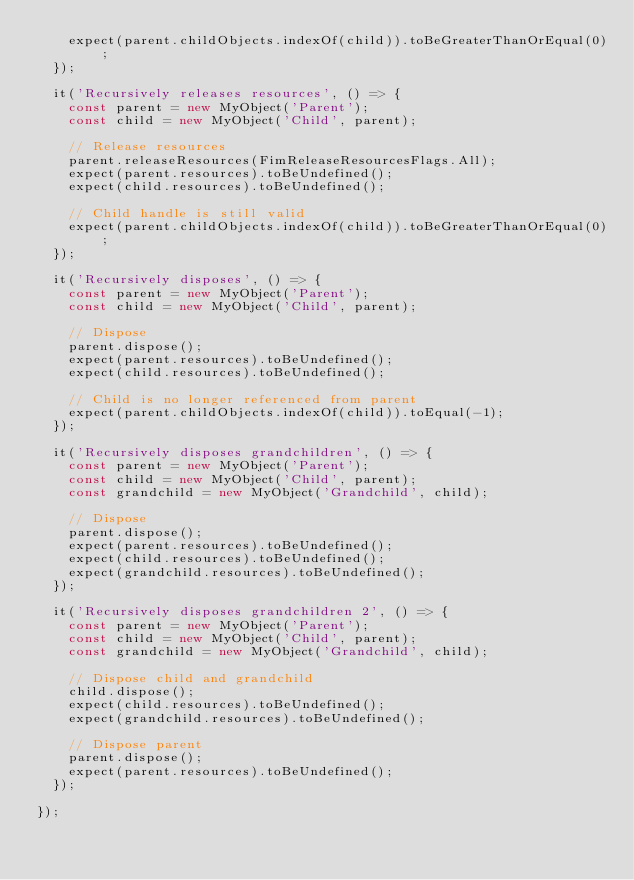Convert code to text. <code><loc_0><loc_0><loc_500><loc_500><_TypeScript_>    expect(parent.childObjects.indexOf(child)).toBeGreaterThanOrEqual(0);
  });

  it('Recursively releases resources', () => {
    const parent = new MyObject('Parent');
    const child = new MyObject('Child', parent);

    // Release resources
    parent.releaseResources(FimReleaseResourcesFlags.All);
    expect(parent.resources).toBeUndefined();
    expect(child.resources).toBeUndefined();

    // Child handle is still valid
    expect(parent.childObjects.indexOf(child)).toBeGreaterThanOrEqual(0);
  });

  it('Recursively disposes', () => {
    const parent = new MyObject('Parent');
    const child = new MyObject('Child', parent);

    // Dispose
    parent.dispose();
    expect(parent.resources).toBeUndefined();
    expect(child.resources).toBeUndefined();

    // Child is no longer referenced from parent
    expect(parent.childObjects.indexOf(child)).toEqual(-1);
  });

  it('Recursively disposes grandchildren', () => {
    const parent = new MyObject('Parent');
    const child = new MyObject('Child', parent);
    const grandchild = new MyObject('Grandchild', child);

    // Dispose
    parent.dispose();
    expect(parent.resources).toBeUndefined();
    expect(child.resources).toBeUndefined();
    expect(grandchild.resources).toBeUndefined();
  });

  it('Recursively disposes grandchildren 2', () => {
    const parent = new MyObject('Parent');
    const child = new MyObject('Child', parent);
    const grandchild = new MyObject('Grandchild', child);

    // Dispose child and grandchild
    child.dispose();
    expect(child.resources).toBeUndefined();
    expect(grandchild.resources).toBeUndefined();

    // Dispose parent
    parent.dispose();
    expect(parent.resources).toBeUndefined();
  });

});
</code> 